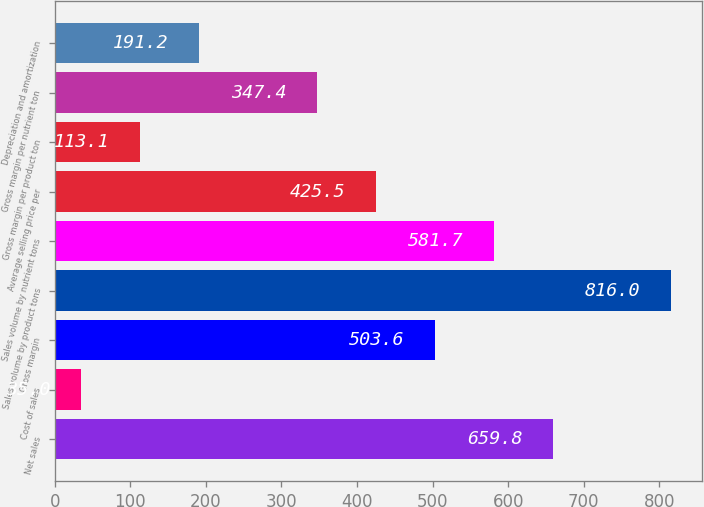Convert chart to OTSL. <chart><loc_0><loc_0><loc_500><loc_500><bar_chart><fcel>Net sales<fcel>Cost of sales<fcel>Gross margin<fcel>Sales volume by product tons<fcel>Sales volume by nutrient tons<fcel>Average selling price per<fcel>Gross margin per product ton<fcel>Gross margin per nutrient ton<fcel>Depreciation and amortization<nl><fcel>659.8<fcel>35<fcel>503.6<fcel>816<fcel>581.7<fcel>425.5<fcel>113.1<fcel>347.4<fcel>191.2<nl></chart> 